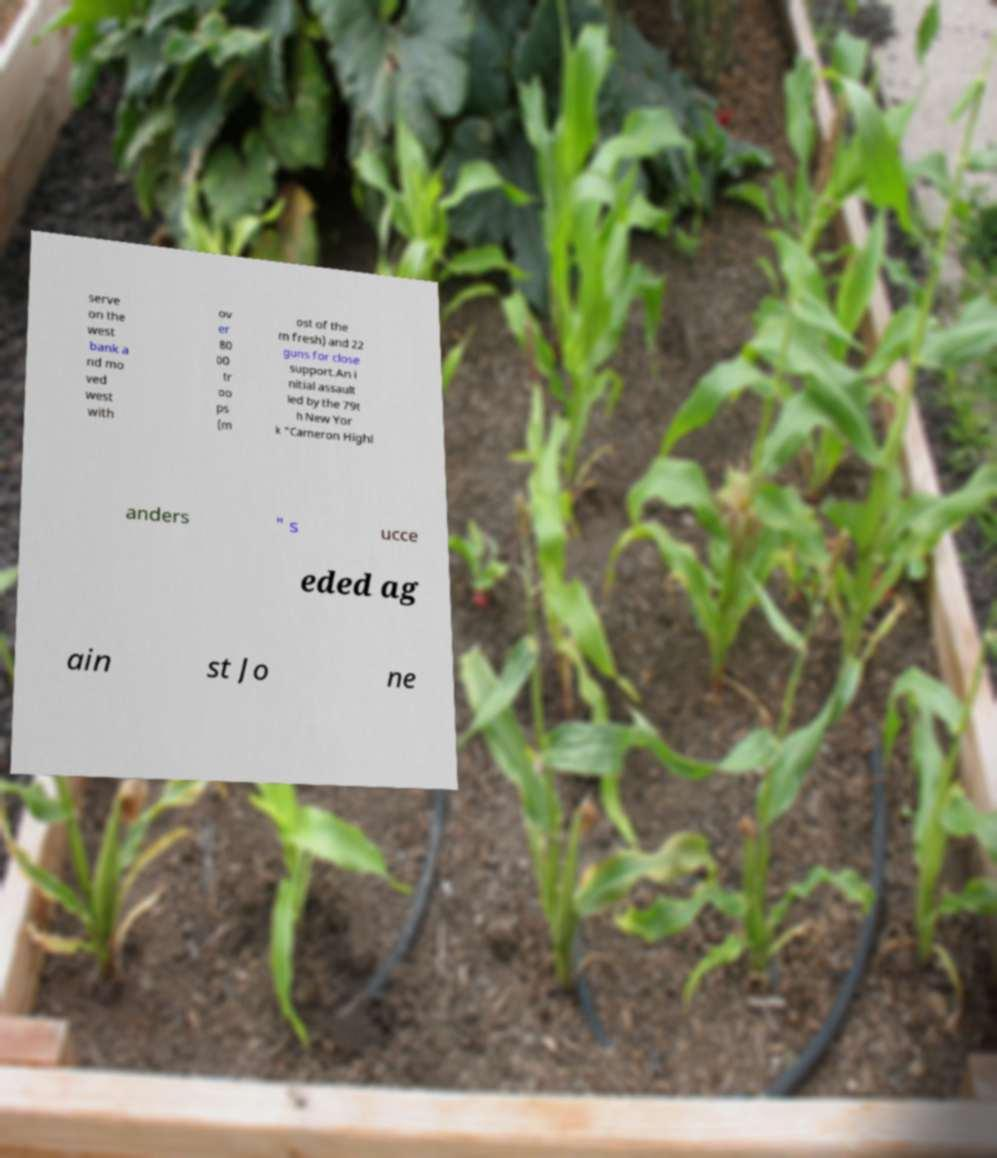There's text embedded in this image that I need extracted. Can you transcribe it verbatim? serve on the west bank a nd mo ved west with ov er 80 00 tr oo ps (m ost of the m fresh) and 22 guns for close support.An i nitial assault led by the 79t h New Yor k "Cameron Highl anders " s ucce eded ag ain st Jo ne 